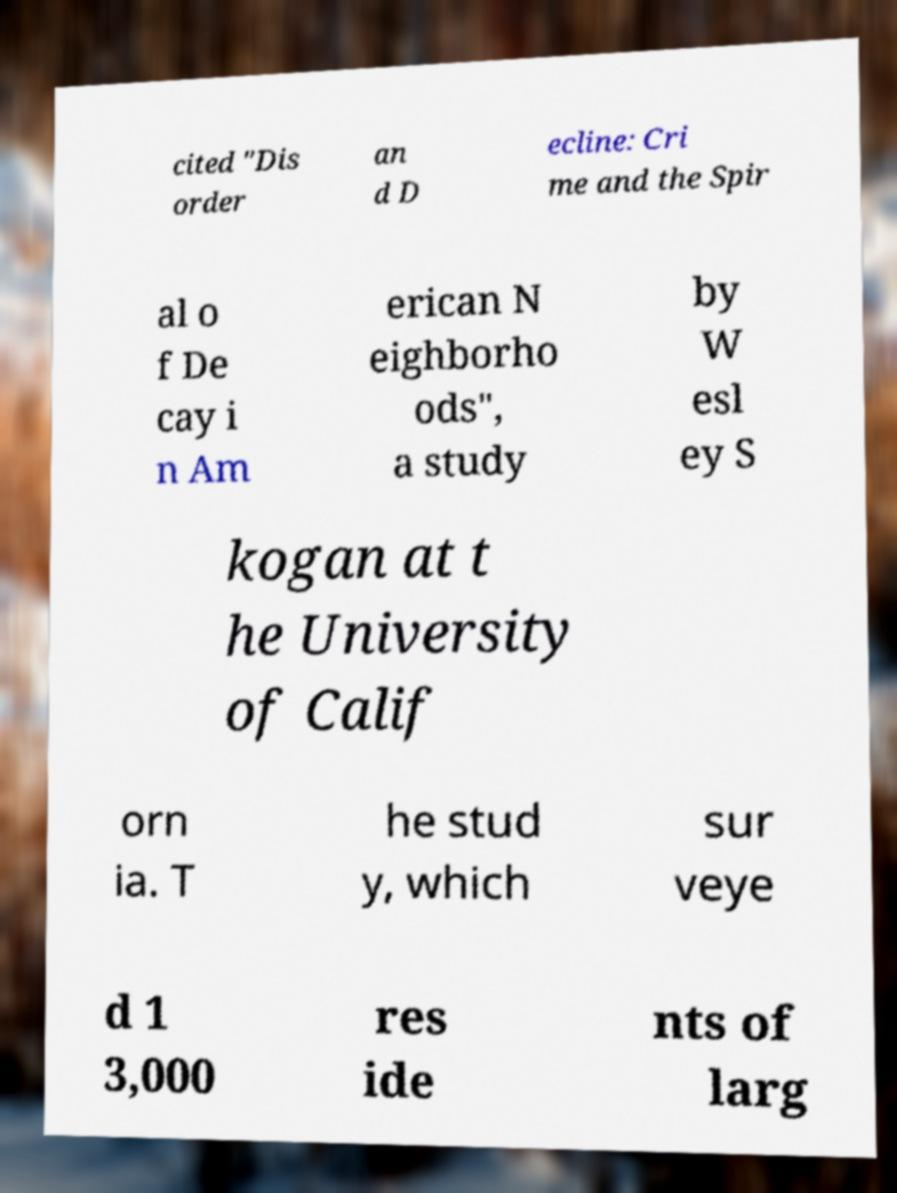Please identify and transcribe the text found in this image. cited "Dis order an d D ecline: Cri me and the Spir al o f De cay i n Am erican N eighborho ods", a study by W esl ey S kogan at t he University of Calif orn ia. T he stud y, which sur veye d 1 3,000 res ide nts of larg 